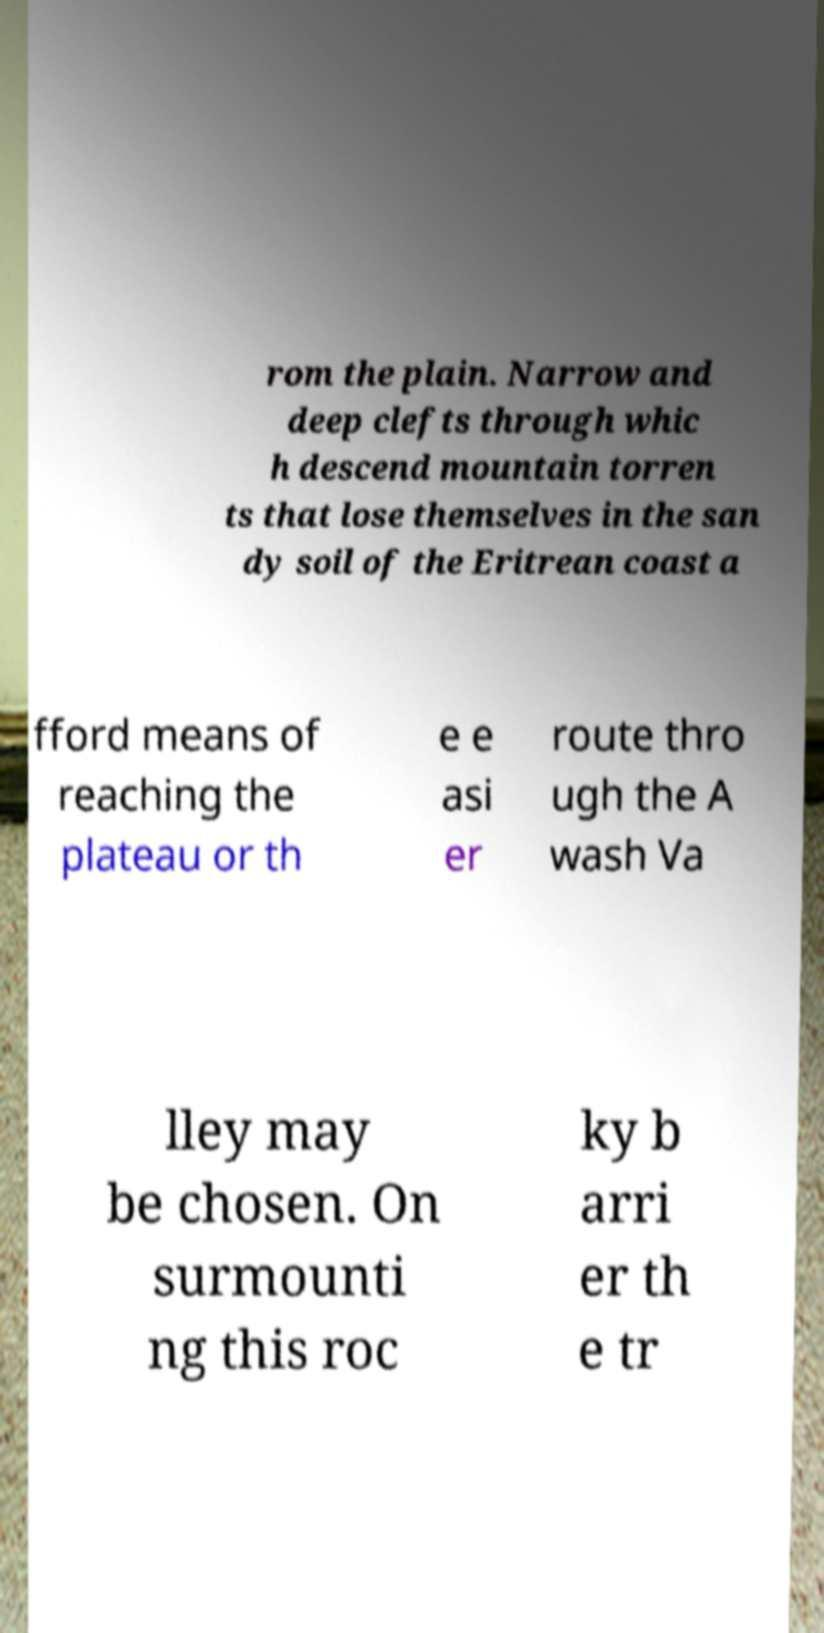Can you accurately transcribe the text from the provided image for me? rom the plain. Narrow and deep clefts through whic h descend mountain torren ts that lose themselves in the san dy soil of the Eritrean coast a fford means of reaching the plateau or th e e asi er route thro ugh the A wash Va lley may be chosen. On surmounti ng this roc ky b arri er th e tr 